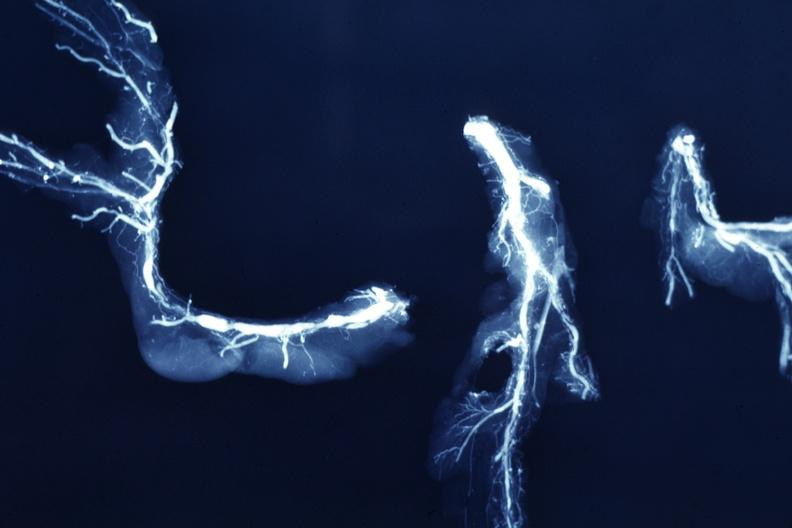does nipple duplication show x-ray postmortdissected arteries extensive lesions?
Answer the question using a single word or phrase. No 